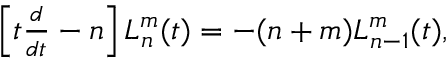Convert formula to latex. <formula><loc_0><loc_0><loc_500><loc_500>\begin{array} { r } { \left [ t \frac { d } { d t } - n \right ] L _ { n } ^ { m } ( t ) = - ( n + m ) L _ { n - 1 } ^ { m } ( t ) , } \end{array}</formula> 